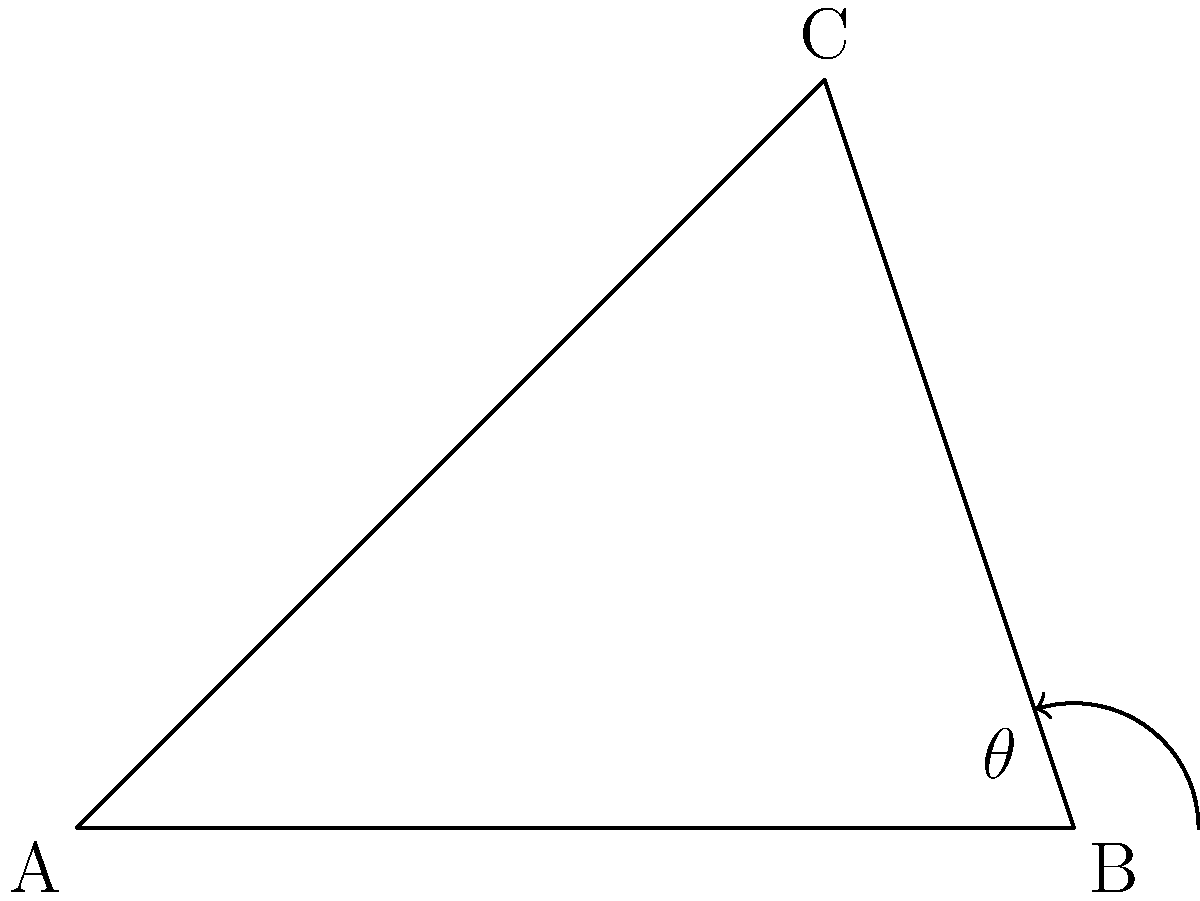As part of a school project on road safety, students are analyzing a map of intersecting roads near the school. In the diagram, two roads intersect at point B, forming an angle $\theta$. If the coordinates of the three points are A(0,0), B(4,0), and C(3,3), what is the measure of angle $\theta$ in degrees? To find the measure of angle $\theta$, we can follow these steps:

1) First, we need to calculate the vectors $\vec{BA}$ and $\vec{BC}$:
   $\vec{BA} = (0-4, 0-0) = (-4, 0)$
   $\vec{BC} = (3-4, 3-0) = (-1, 3)$

2) Next, we can use the dot product formula to find the cosine of the angle:
   $\cos \theta = \frac{\vec{BA} \cdot \vec{BC}}{|\vec{BA}||\vec{BC}|}$

3) Calculate the dot product $\vec{BA} \cdot \vec{BC}$:
   $\vec{BA} \cdot \vec{BC} = (-4)(-1) + (0)(3) = 4$

4) Calculate the magnitudes:
   $|\vec{BA}| = \sqrt{(-4)^2 + 0^2} = 4$
   $|\vec{BC}| = \sqrt{(-1)^2 + 3^2} = \sqrt{10}$

5) Substitute into the cosine formula:
   $\cos \theta = \frac{4}{4\sqrt{10}} = \frac{1}{\sqrt{10}}$

6) Take the inverse cosine (arccos) of both sides:
   $\theta = \arccos(\frac{1}{\sqrt{10}})$

7) Convert to degrees:
   $\theta = \arccos(\frac{1}{\sqrt{10}}) \cdot \frac{180}{\pi} \approx 71.57°$

Therefore, the measure of angle $\theta$ is approximately 71.57°.
Answer: $71.57°$ 